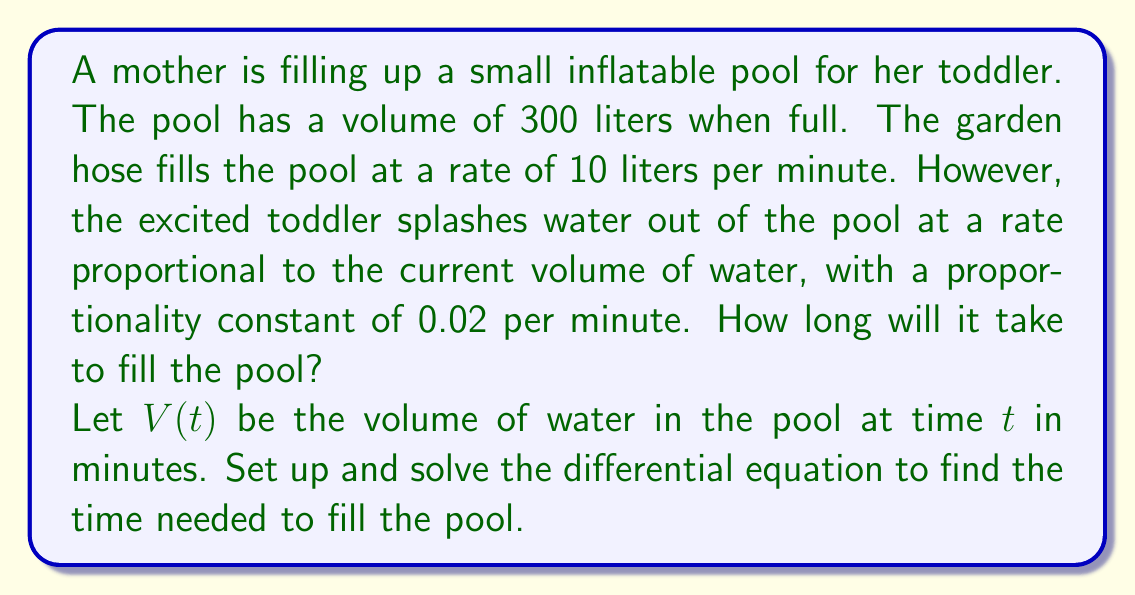Show me your answer to this math problem. Let's approach this problem step by step:

1) First, we need to set up the differential equation. The rate of change of the volume is the difference between the rate of water entering and the rate of water leaving:

   $$\frac{dV}{dt} = 10 - 0.02V$$

2) This is a first-order linear differential equation. We can solve it using the integrating factor method.

3) The integrating factor is $e^{\int 0.02 dt} = e^{0.02t}$

4) Multiplying both sides of the equation by the integrating factor:

   $$e^{0.02t}\frac{dV}{dt} + 0.02Ve^{0.02t} = 10e^{0.02t}$$

5) The left side is now the derivative of $Ve^{0.02t}$. So we can write:

   $$\frac{d}{dt}(Ve^{0.02t}) = 10e^{0.02t}$$

6) Integrating both sides:

   $$Ve^{0.02t} = 500e^{0.02t} + C$$

7) Solving for V:

   $$V = 500 + Ce^{-0.02t}$$

8) At t = 0, V = 0, so we can find C:

   $$0 = 500 + C$$
   $$C = -500$$

9) Therefore, the solution is:

   $$V = 500 - 500e^{-0.02t}$$

10) We want to find when V = 300. Substituting:

    $$300 = 500 - 500e^{-0.02t}$$

11) Solving for t:

    $$500e^{-0.02t} = 200$$
    $$e^{-0.02t} = 0.4$$
    $$-0.02t = \ln(0.4)$$
    $$t = -\frac{\ln(0.4)}{0.02} \approx 45.96$$

Therefore, it will take approximately 46 minutes to fill the pool.
Answer: $t \approx 46$ minutes 